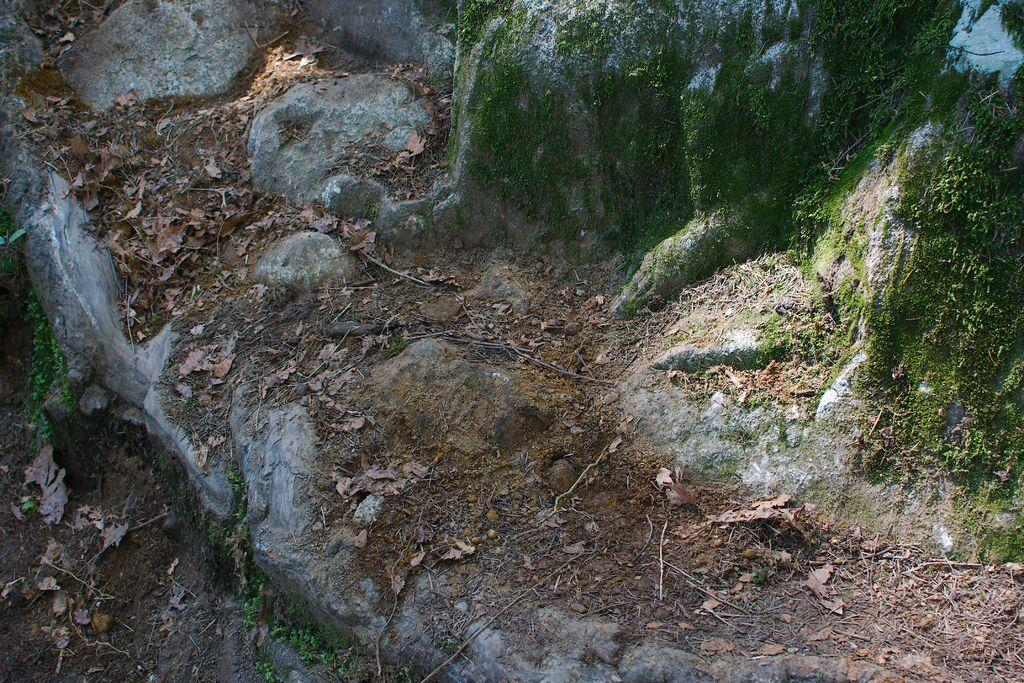What type of natural elements can be seen on the ground in the image? There are rocks on the ground in the image. What type of plant material is present in the image? There are leaves and grass in the image. What type of neck accessory can be seen in the image? There is no neck accessory present in the image. What type of knowledge is being shared in the image? There is no knowledge being shared in the image; it primarily features natural elements. 